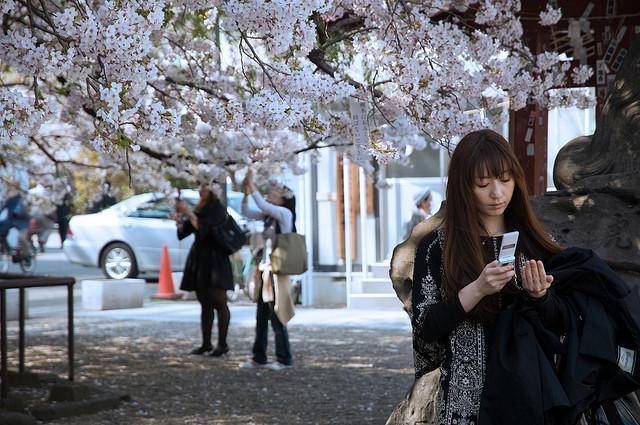How many people are talking on their phones?
Give a very brief answer. 0. How many cars are there?
Give a very brief answer. 1. How many people are there?
Give a very brief answer. 3. How many dogs are there?
Give a very brief answer. 0. 